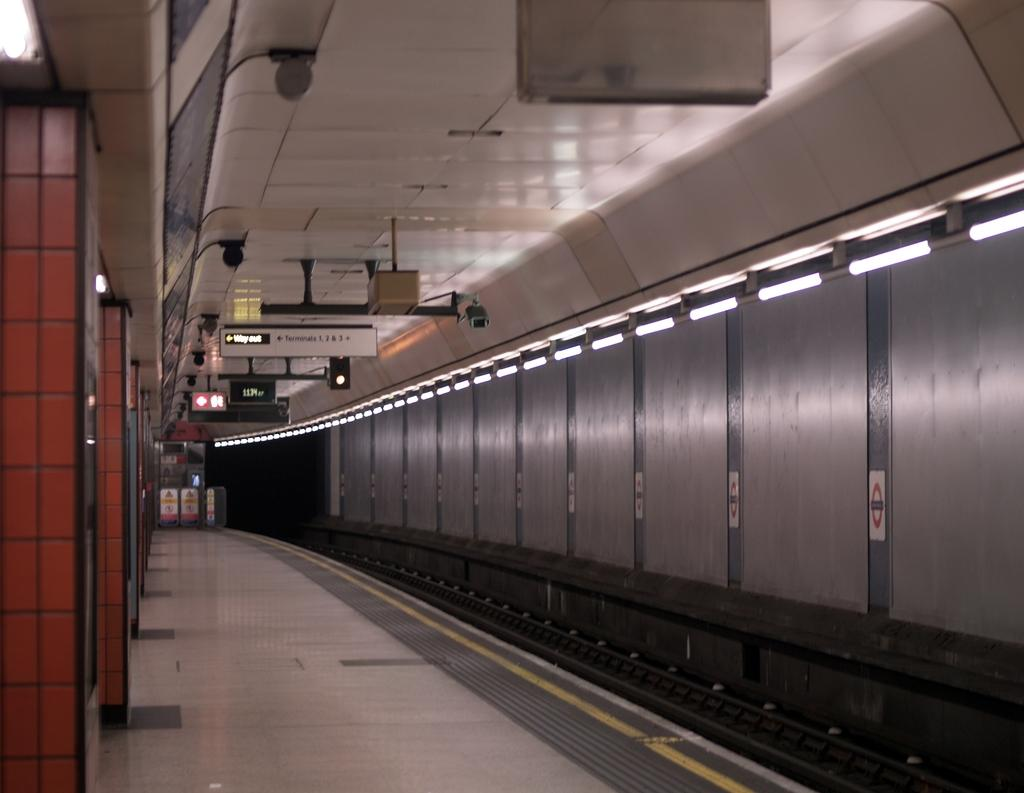What can be seen on the right side of the image? There is a track on the right side of the image. What is present on the ceiling in the image? There are lights and boards attached to the ceiling. What can be seen on the left side of the image? There are pillars on the left side of the image. What type of carpenter is responsible for the loss of taste in the image? There is no carpenter or loss of taste present in the image. What flavor of ice cream is being served in the image? There is no ice cream or taste mentioned in the image. 